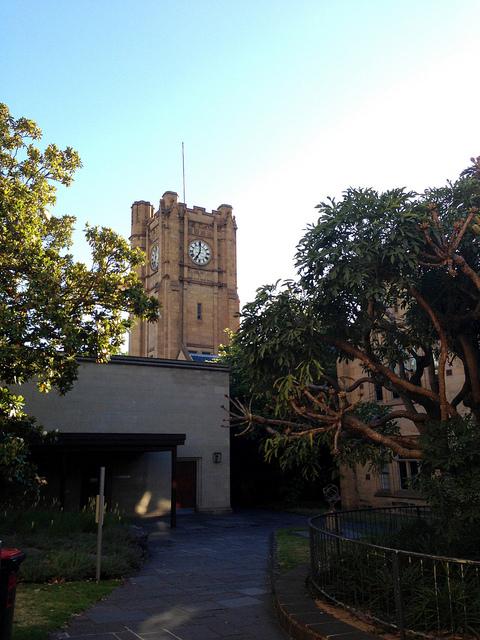How many plant pots are in the lower right quadrant of the photo?
Give a very brief answer. 0. What number of trees are on this scene?
Concise answer only. 2. Can you tell what time it is from this distance?
Concise answer only. Yes. What kind of building is the clock on?
Quick response, please. Tower. Have the bushes been trimmed?
Short answer required. Yes. How many round objects in the picture?
Be succinct. 1. What do some of the houses have to let in light?
Concise answer only. Windows. Is the pathway clean or dirty?
Short answer required. Clean. 